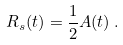Convert formula to latex. <formula><loc_0><loc_0><loc_500><loc_500>R _ { s } ( t ) = \frac { 1 } { 2 } A ( t ) \, .</formula> 